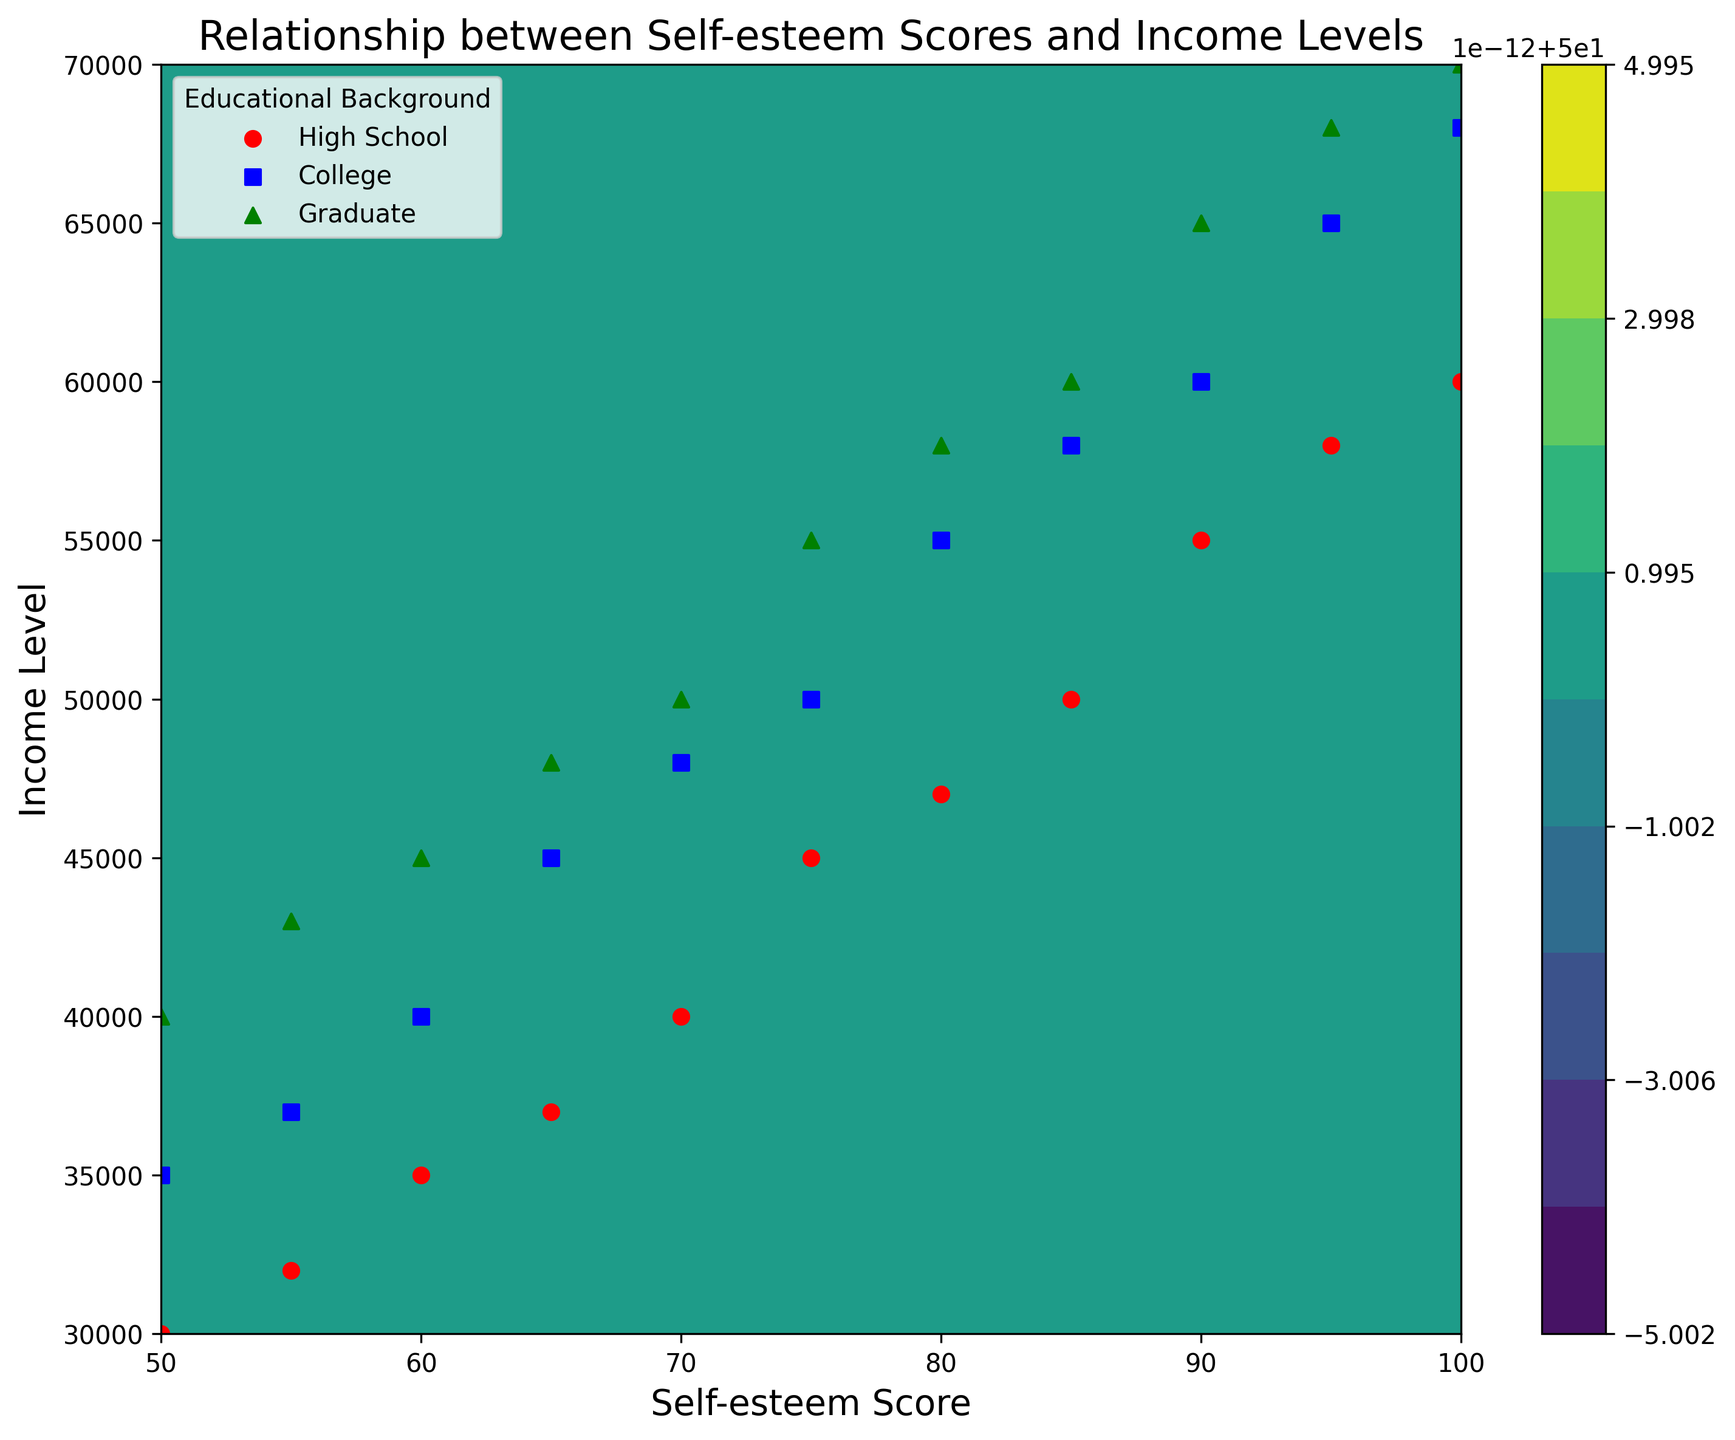What is the range of income levels for individuals with a self-esteem score of 75? To determine this, look at the scatter points and contour lines where self-esteem is 75. Observe the income levels corresponding to these points.
Answer: 45000 to 55000 Which educational background shows a higher increase in income level with increasing self-esteem: High School or College? Compare the slope of the scatter markers for "High School" and "College." The slope for "College" markers is steeper, indicating a higher increase in income with self-esteem.
Answer: College Which educational background has the highest income level at a self-esteem score of 100? Check the scatter points for each educational background at a self-esteem score of 100. The point highest on the income scale represents the highest income at this self-esteem level.
Answer: Graduate At an income level of 60000, which educational background exhibits the highest self-esteem scores? Locate the income level of 60000 on the Y-axis and see which educational background's scatter points have the highest self-esteem scores.
Answer: Graduate What are the average income levels for educational backgrounds at a self-esteem score of 85? Identify the specific data points at a self-esteem score of 85 for each educational background and calculate the average income levels: (50000 + 58000 + 60000)/3.
Answer: 56000 How do the contour lines visually indicate the overall relationship between self-esteem and income levels? Contour lines visually show regions of similar values. If lines are closer together, it indicates a steeper relationship, whereas lines further apart indicate a more gradual relationship.
Answer: closer lines indicate steeper relationships Which color represents the highest density of income levels across self-esteem scores? Observe the contour plot and determine which color bands correspond to the highest value range. The darker the color, the higher the density.
Answer: Dark green Does the income level variance increase or decrease as self-esteem scores rise from 50 to 100? Evaluate the scatter points spread across different self-esteem scores. A larger spread as scores increase indicates increased variance in income levels.
Answer: Increase At what income level does the "High School" educational background show a significant rise in self-esteem scores? Look at the scatter points for "High School" and identify where there is a noticeable steep increase in self-esteem.
Answer: 45000 to 50000 What is the primary trend of the relationship between self-esteem and income across all educational backgrounds together? Assess the contour lines' direction and scatter points globally to see if income generally increases with self-esteem or not.
Answer: Positive correlation 